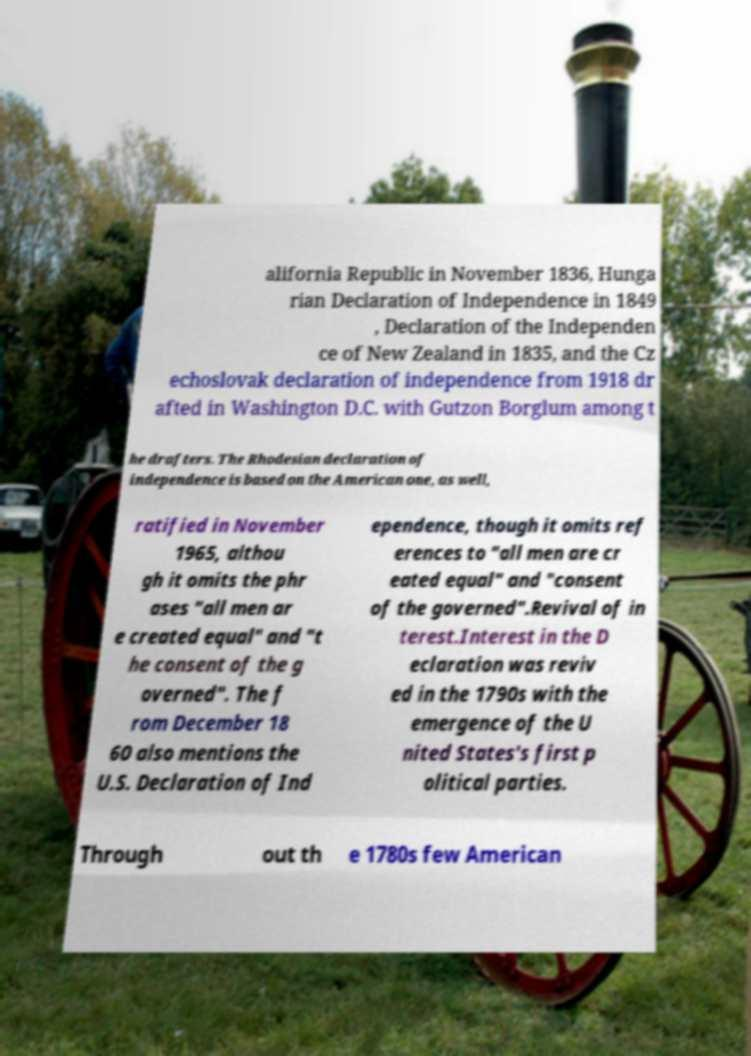Please identify and transcribe the text found in this image. alifornia Republic in November 1836, Hunga rian Declaration of Independence in 1849 , Declaration of the Independen ce of New Zealand in 1835, and the Cz echoslovak declaration of independence from 1918 dr afted in Washington D.C. with Gutzon Borglum among t he drafters. The Rhodesian declaration of independence is based on the American one, as well, ratified in November 1965, althou gh it omits the phr ases "all men ar e created equal" and "t he consent of the g overned". The f rom December 18 60 also mentions the U.S. Declaration of Ind ependence, though it omits ref erences to "all men are cr eated equal" and "consent of the governed".Revival of in terest.Interest in the D eclaration was reviv ed in the 1790s with the emergence of the U nited States's first p olitical parties. Through out th e 1780s few American 